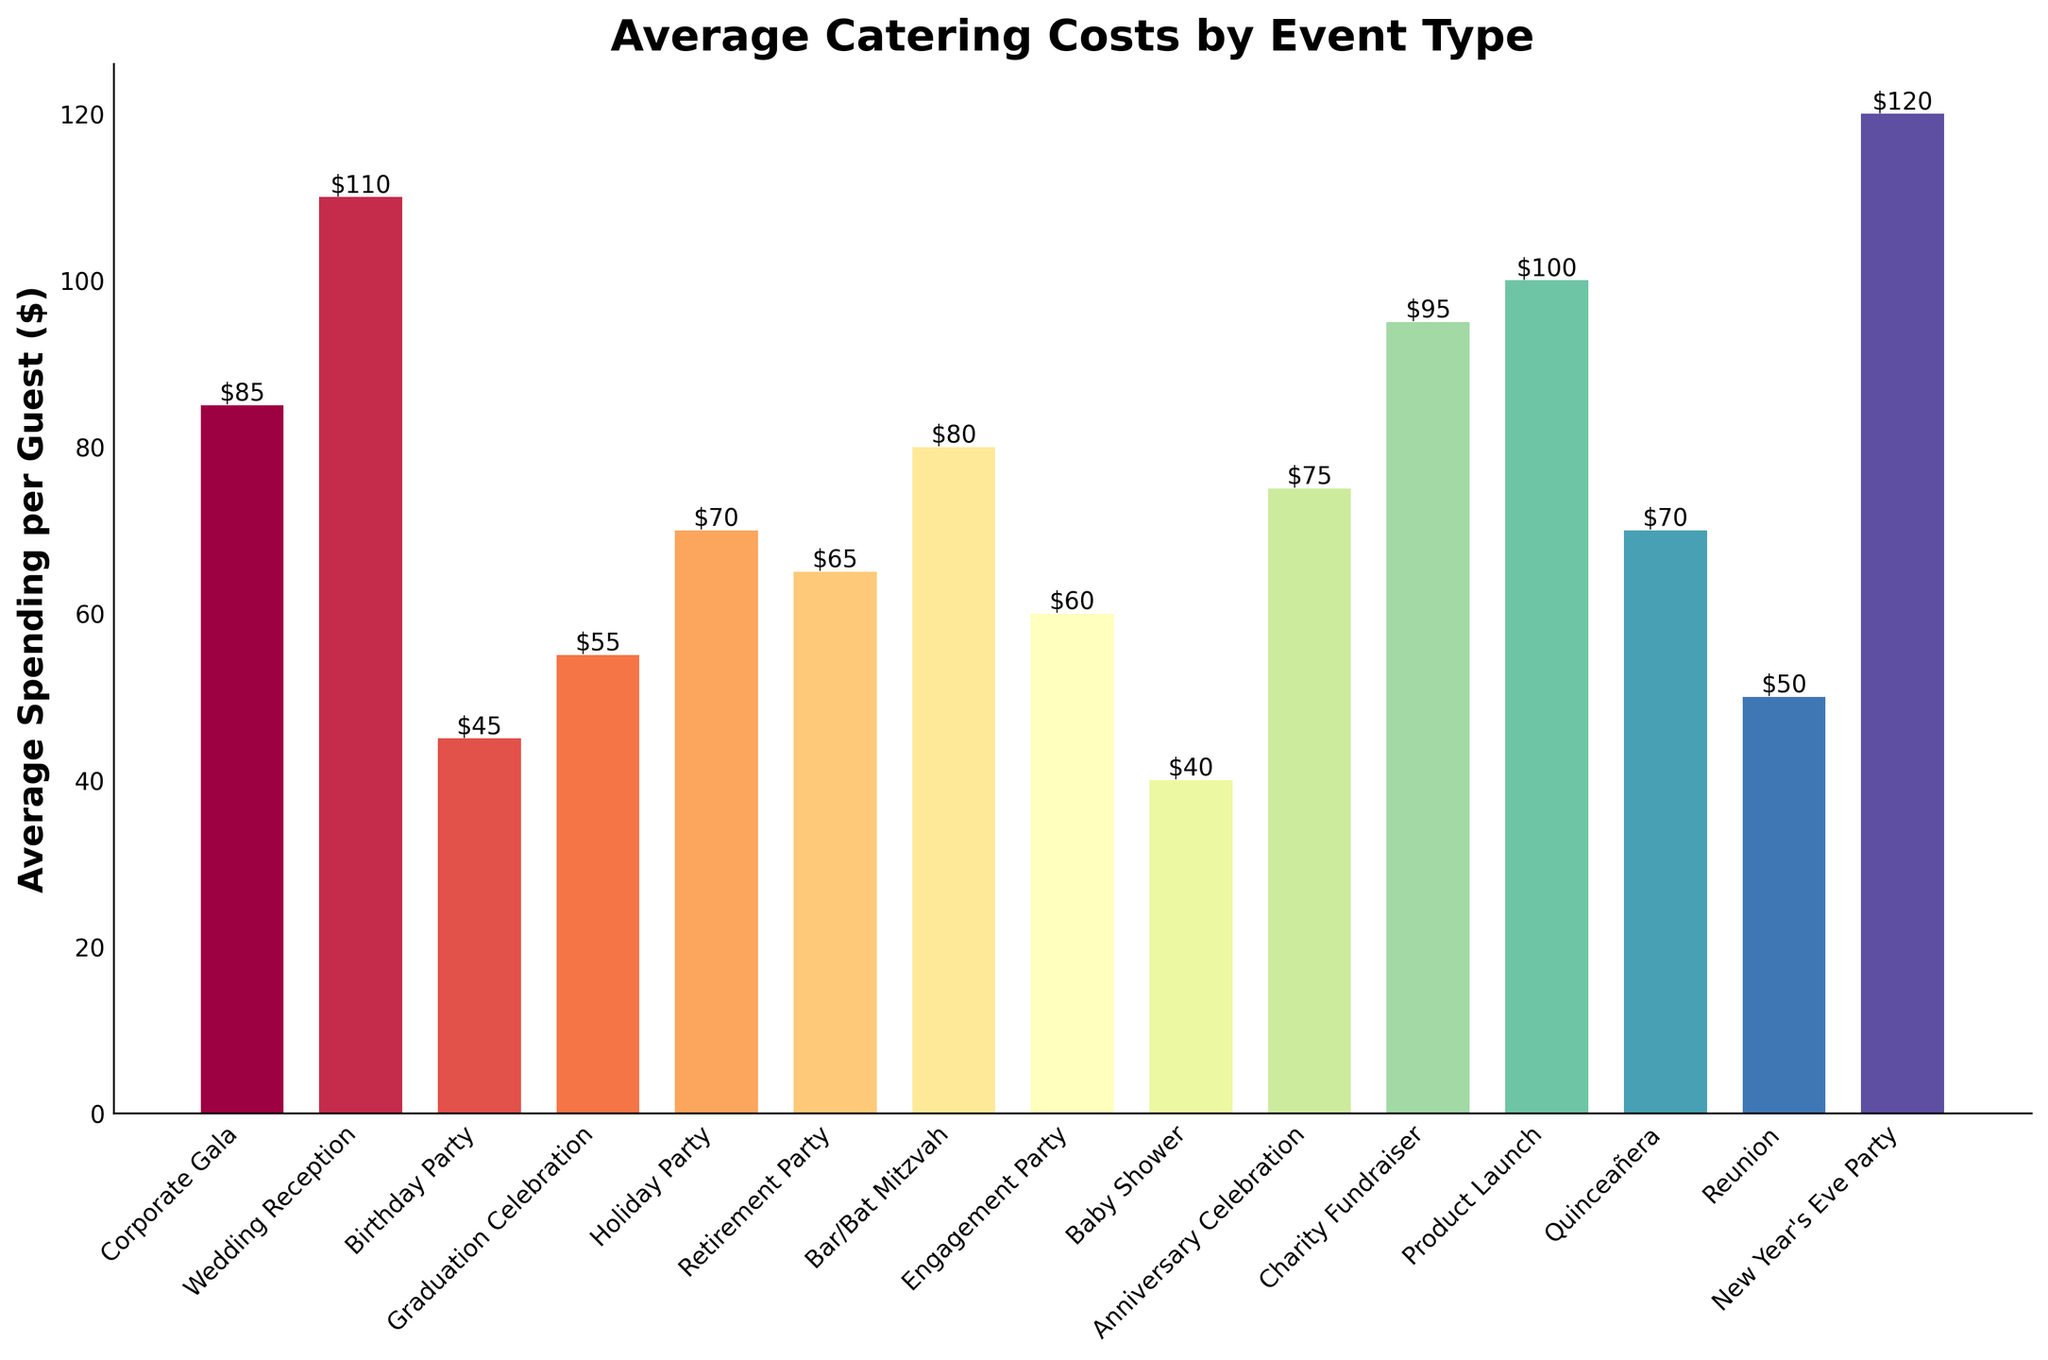What is the event type with the highest average spending per guest? To determine the event type with the highest average spending per guest, look for the bar with the greatest height. The highest bar represents the event with the most spending per guest.
Answer: New Year's Eve Party Which event type has a lower average spending per guest, Baby Shower or Engagement Party? Compare the heights of the bars for Baby Shower and Engagement Party. The bar lower in height represents the event type with less spending per guest.
Answer: Baby Shower What is the difference in average spending per guest between a Wedding Reception and a Quinceañera? Find the heights of the bars for Wedding Reception and Quinceañera. Subtract the shorter height (Quinceañera) from the taller height (Wedding Reception) to get the difference. Wedding Reception is $110 and Quinceañera is $70. $110 - $70 = $40.
Answer: $40 Which event type has an average spending per guest of $65? Look for the bar labeled with the value closest to $65. This indicates the event type with that average spending per guest.
Answer: Retirement Party What is the total average spending per guest for Corporate Gala, Holiday Party, and Charity Fundraiser combined? Identify the spending for Corporate Gala ($85), Holiday Party ($70), and Charity Fundraiser ($95). Sum these amounts: $85 + $70 + $95 = $250.
Answer: $250 Which two event types have the same average spending per guest? Check bars with identical heights or labels showing the same value.
Answer: Holiday Party and Quinceañera Is the average spending per guest for a Product Launch higher than that for a Corporate Gala? Compare the heights of the bars for Product Launch and Corporate Gala. Product Launch is $100 while Corporate Gala is $85. Since $100 is greater than $85, the answer is yes.
Answer: Yes Which events have average spending per guest equal to or more than $100? Identify the bars with heights equal to or above the $100 mark. The events associated with these bars are the ones sought.
Answer: Wedding Reception, Product Launch, New Year's Eve Party What is the average spending per guest for the middle three event types when sorted from lowest to highest spending? Sort the events by average spending per guest: [Baby Shower, Birthday Party, Graduation Celebration, Reunion, Engagement Party, Retirement Party, Holiday Party, Quinceañera, Anniversary Celebration, Corporate Gala, Bar/Bat Mitzvah, Charity Fundraiser, Product Launch, Wedding Reception, New Year's Eve Party]. The middle three are Reunion ($50), Engagement Party ($60), and Retirement Party ($65). Calculate the average: ($50 + $60 + $65) / 3 = $175 / 3 ≈ $58.33.
Answer: $58.33 How many event types have an average spending per guest of less than $50? Count the bars with heights less than the $50 mark. The events are: Birthday Party and Baby Shower.
Answer: 2 